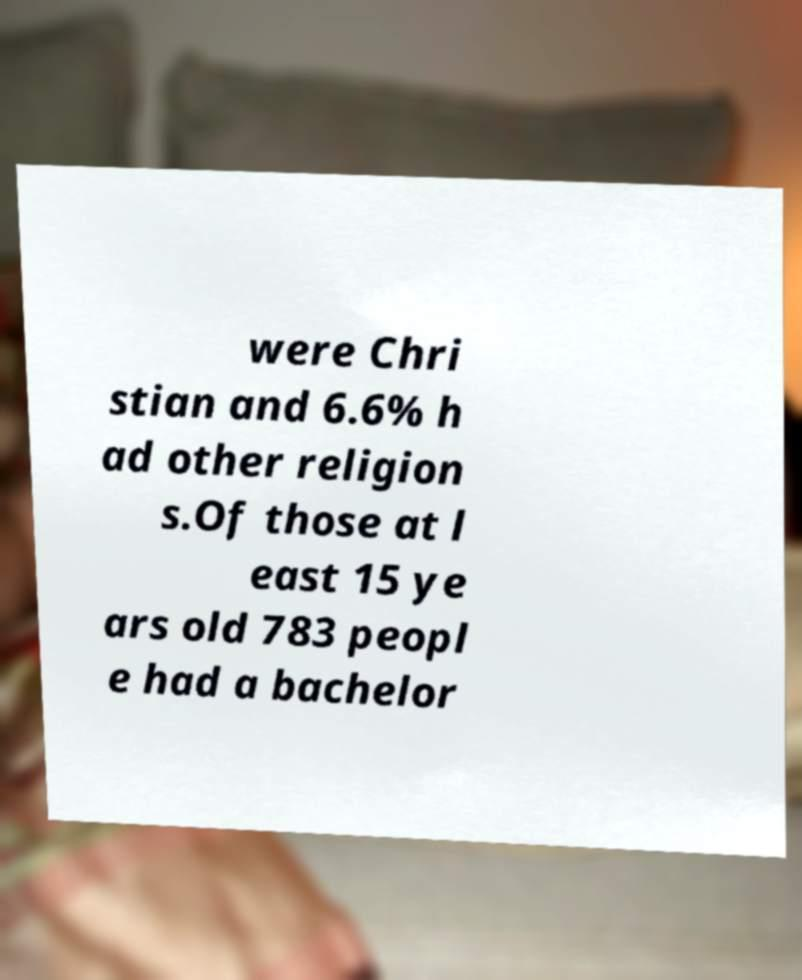Please read and relay the text visible in this image. What does it say? were Chri stian and 6.6% h ad other religion s.Of those at l east 15 ye ars old 783 peopl e had a bachelor 